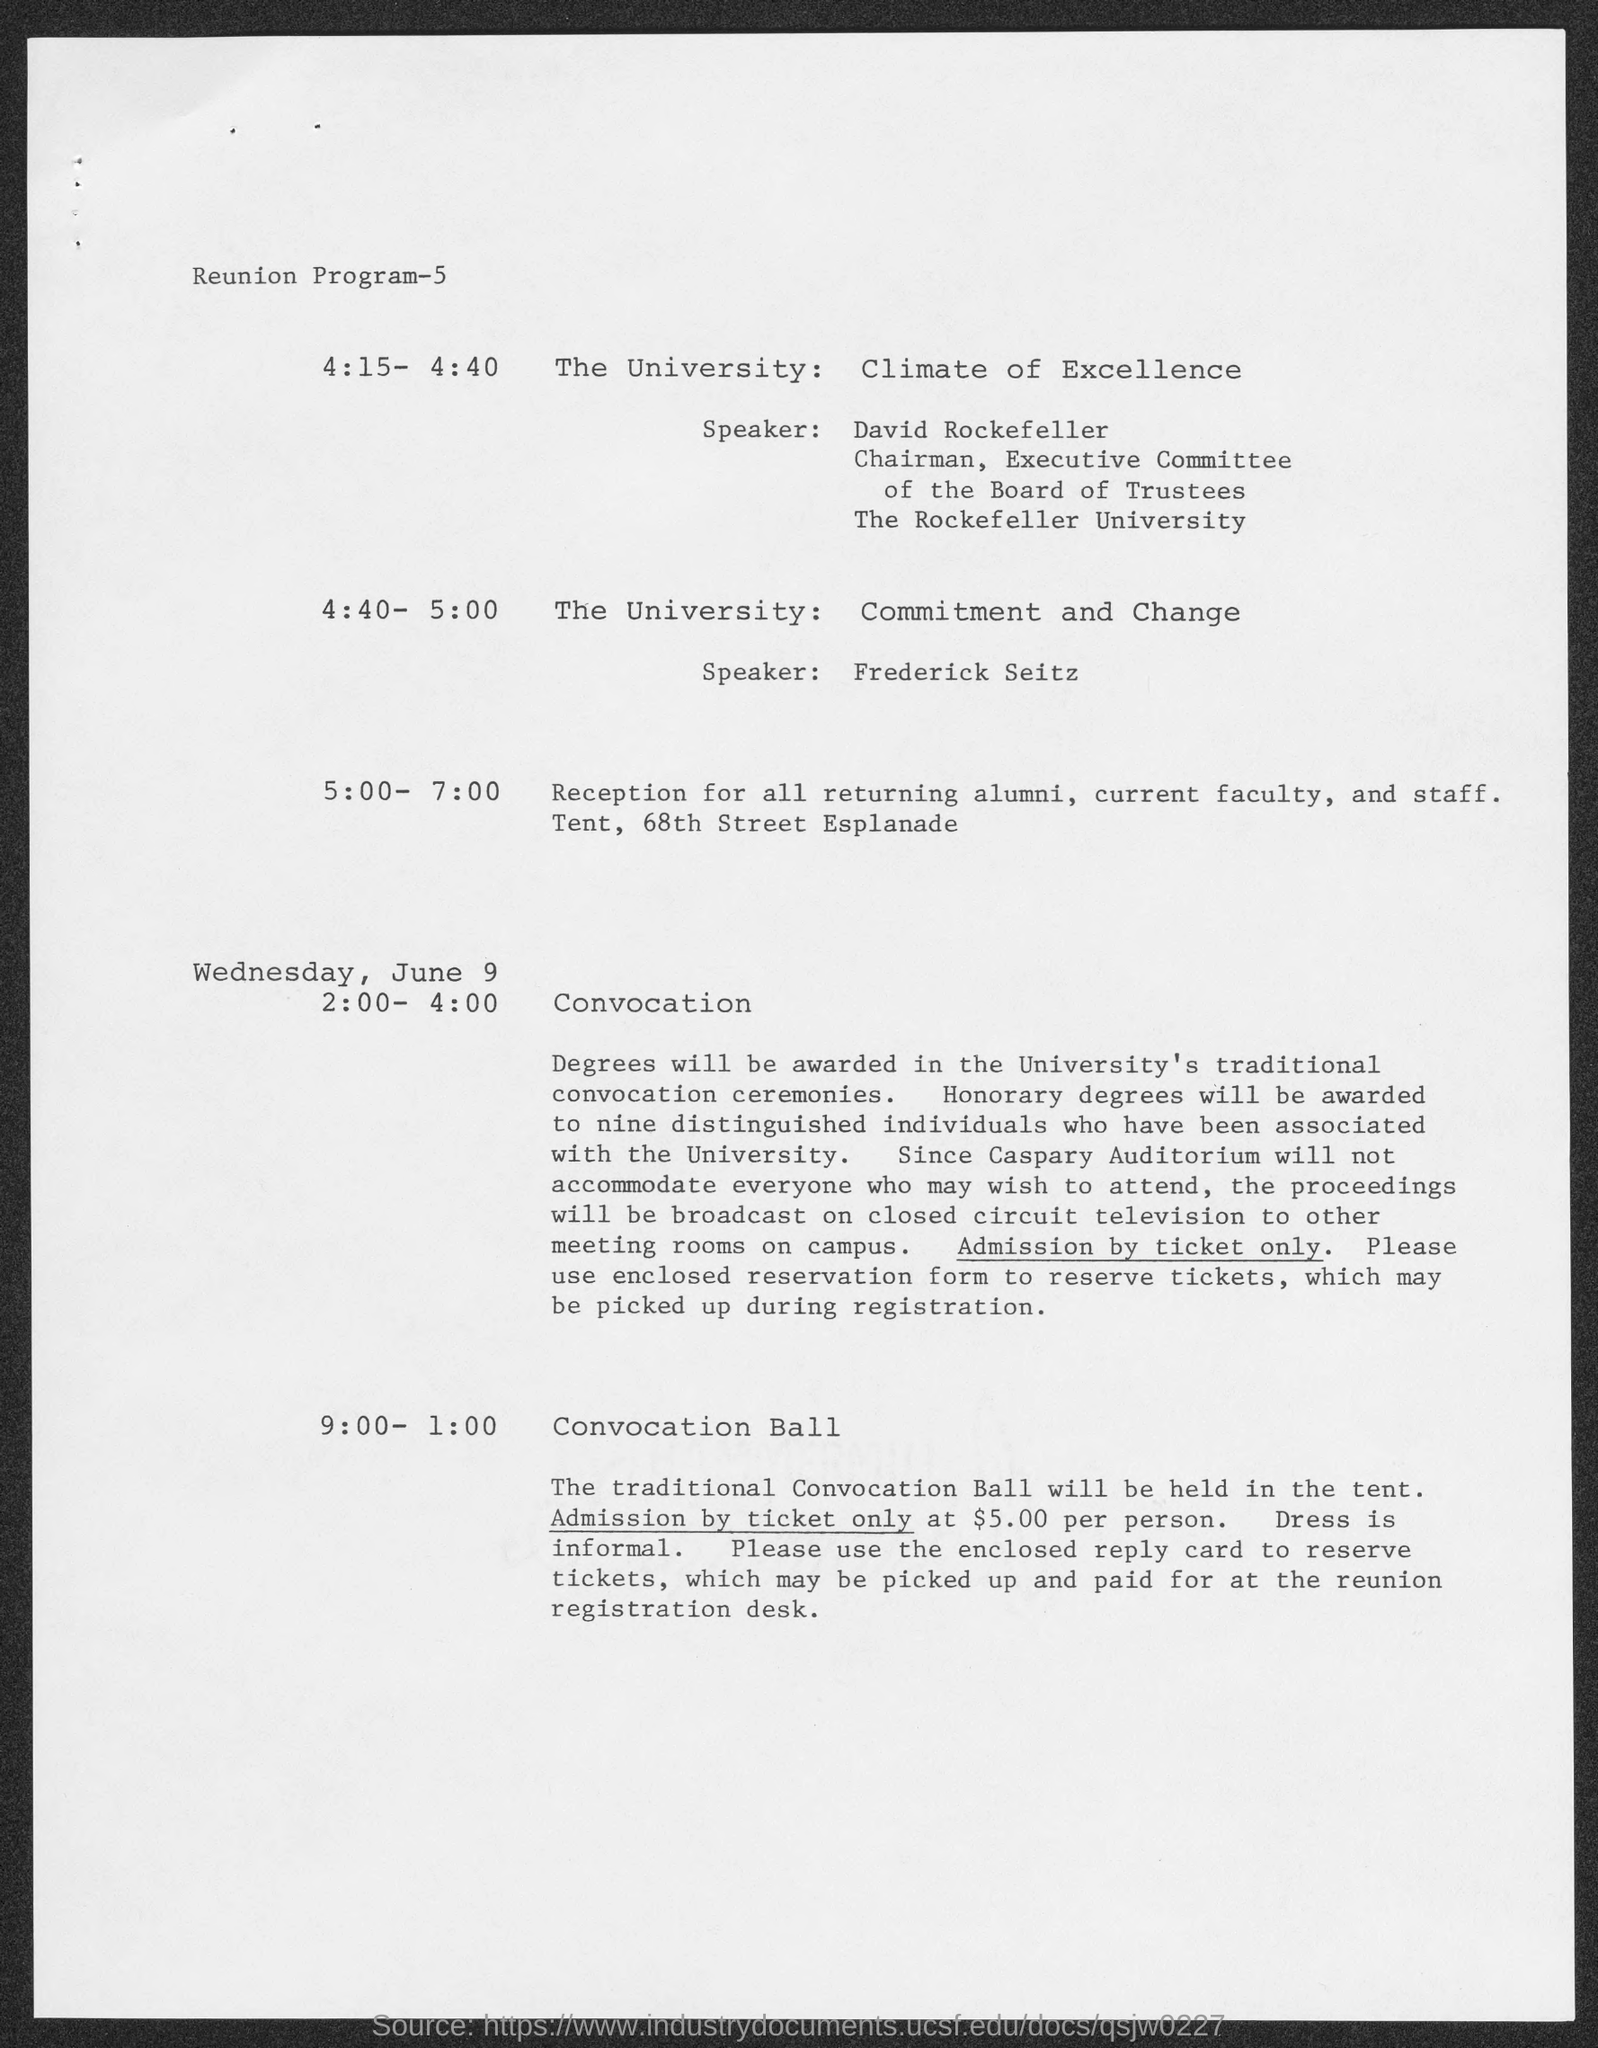List a handful of essential elements in this visual. David Rockefeller belongs to The Rockefeller University. The speaker for The University: Commitment and Change? is Frederick Seitz. The speaker for The University: Climate of Excellence is David Rockefeller. 